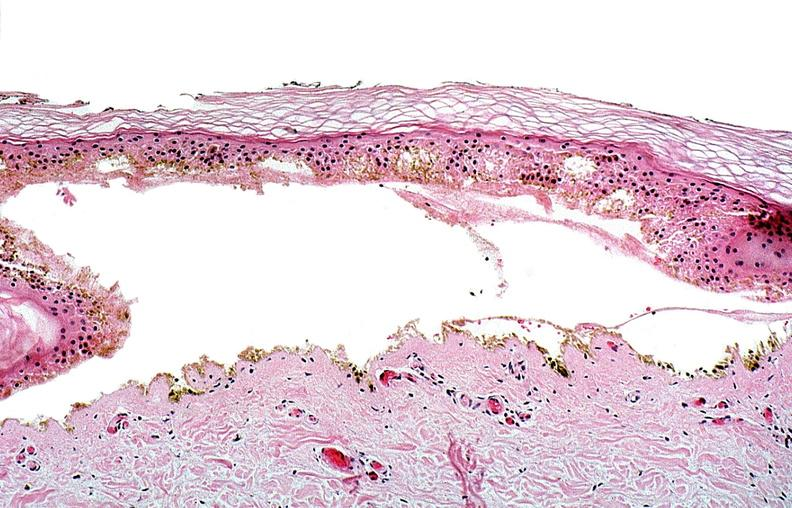where is this?
Answer the question using a single word or phrase. Skin 